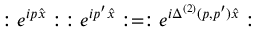Convert formula to latex. <formula><loc_0><loc_0><loc_500><loc_500>\colon e ^ { i p \widehat { x } } \colon \, \colon e ^ { i p ^ { \prime } \widehat { x } } \colon = \colon e ^ { i \Delta ^ { ( 2 ) } ( p , p ^ { \prime } ) \widehat { x } } \colon</formula> 